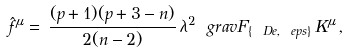Convert formula to latex. <formula><loc_0><loc_0><loc_500><loc_500>\hat { f } ^ { \mu } = \, \frac { ( p + 1 ) ( p + 3 - n ) } { 2 ( n - 2 ) } \, \lambda ^ { 2 } \ g r a v F _ { \{ \ D e , \ e p s \} } \, K ^ { \mu } \, ,</formula> 